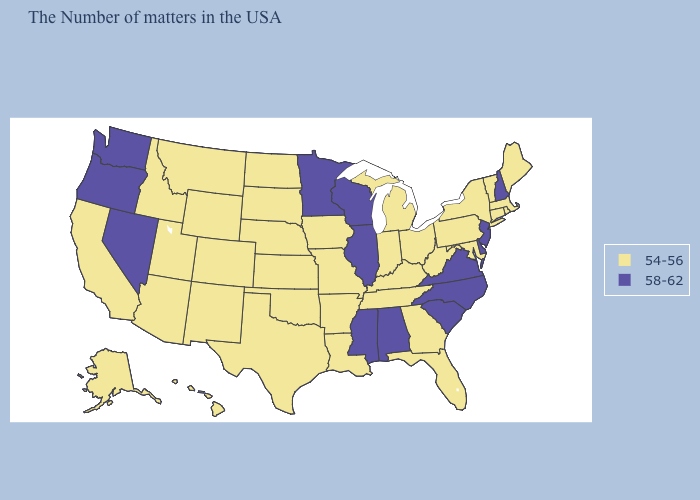What is the value of Texas?
Short answer required. 54-56. Among the states that border Vermont , does Massachusetts have the lowest value?
Answer briefly. Yes. Name the states that have a value in the range 58-62?
Concise answer only. New Hampshire, New Jersey, Delaware, Virginia, North Carolina, South Carolina, Alabama, Wisconsin, Illinois, Mississippi, Minnesota, Nevada, Washington, Oregon. Name the states that have a value in the range 58-62?
Give a very brief answer. New Hampshire, New Jersey, Delaware, Virginia, North Carolina, South Carolina, Alabama, Wisconsin, Illinois, Mississippi, Minnesota, Nevada, Washington, Oregon. What is the value of Idaho?
Short answer required. 54-56. Does New Hampshire have the highest value in the USA?
Quick response, please. Yes. What is the value of Minnesota?
Quick response, please. 58-62. Name the states that have a value in the range 58-62?
Keep it brief. New Hampshire, New Jersey, Delaware, Virginia, North Carolina, South Carolina, Alabama, Wisconsin, Illinois, Mississippi, Minnesota, Nevada, Washington, Oregon. Among the states that border Illinois , which have the lowest value?
Quick response, please. Kentucky, Indiana, Missouri, Iowa. Name the states that have a value in the range 58-62?
Quick response, please. New Hampshire, New Jersey, Delaware, Virginia, North Carolina, South Carolina, Alabama, Wisconsin, Illinois, Mississippi, Minnesota, Nevada, Washington, Oregon. What is the lowest value in states that border Washington?
Give a very brief answer. 54-56. What is the value of Louisiana?
Keep it brief. 54-56. Is the legend a continuous bar?
Concise answer only. No. Name the states that have a value in the range 58-62?
Keep it brief. New Hampshire, New Jersey, Delaware, Virginia, North Carolina, South Carolina, Alabama, Wisconsin, Illinois, Mississippi, Minnesota, Nevada, Washington, Oregon. Name the states that have a value in the range 54-56?
Write a very short answer. Maine, Massachusetts, Rhode Island, Vermont, Connecticut, New York, Maryland, Pennsylvania, West Virginia, Ohio, Florida, Georgia, Michigan, Kentucky, Indiana, Tennessee, Louisiana, Missouri, Arkansas, Iowa, Kansas, Nebraska, Oklahoma, Texas, South Dakota, North Dakota, Wyoming, Colorado, New Mexico, Utah, Montana, Arizona, Idaho, California, Alaska, Hawaii. 